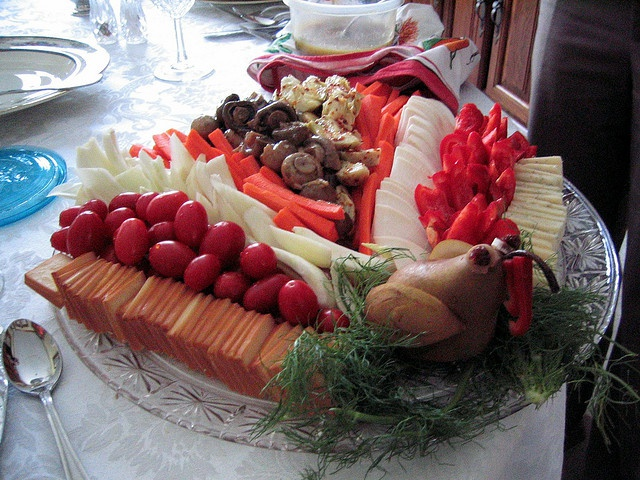Describe the objects in this image and their specific colors. I can see dining table in lightblue, black, darkgray, white, and maroon tones, people in lightblue, black, gray, and darkgray tones, spoon in lightblue, darkgray, gray, and black tones, bowl in lightblue, darkgray, lightgray, and tan tones, and carrot in lightblue, brown, salmon, and red tones in this image. 